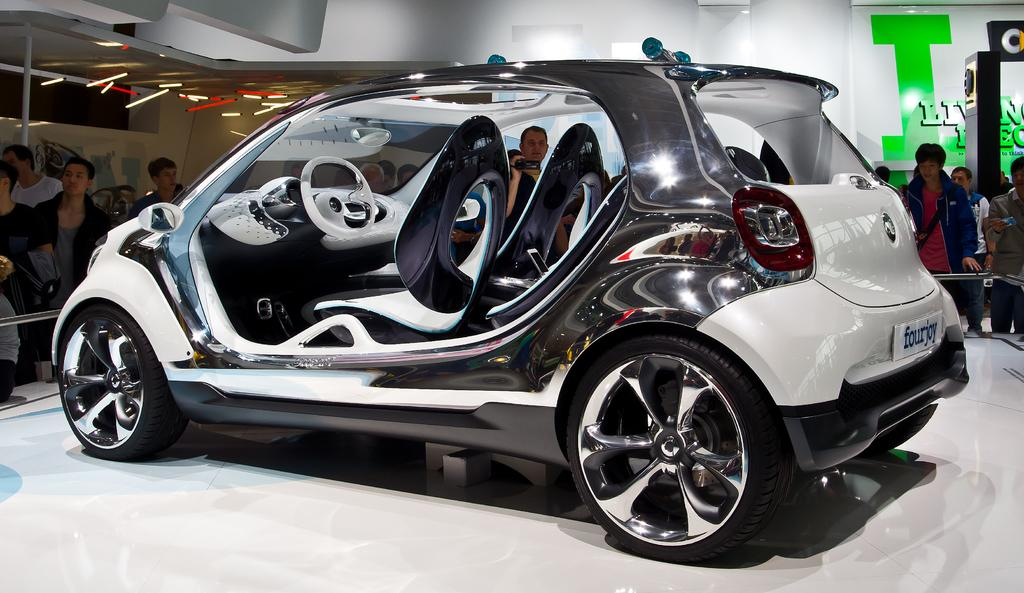What is the main subject of the image? The main subject of the image is a car. Can you describe the color of the car? The car is white in color. What else can be seen in the image besides the car? There are people standing around the car. What type of memory is being discussed by the people standing around the car? There is no indication in the image that the people are discussing any type of memory. 